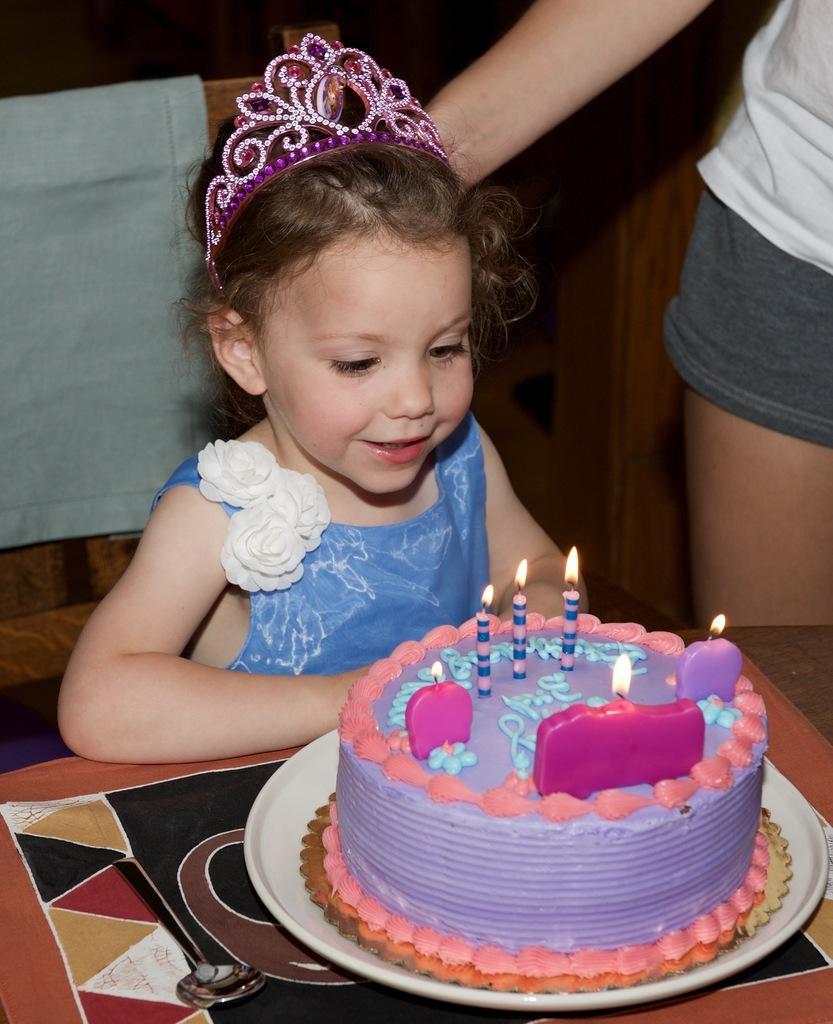In one or two sentences, can you explain what this image depicts? In this image, we can see a kid wearing a crown and in the background, there is a person and we can see a cloth on the stand. At the bottom, there is a cake on the plate and we can see candles, which are light and there is a mat and a spoon. 